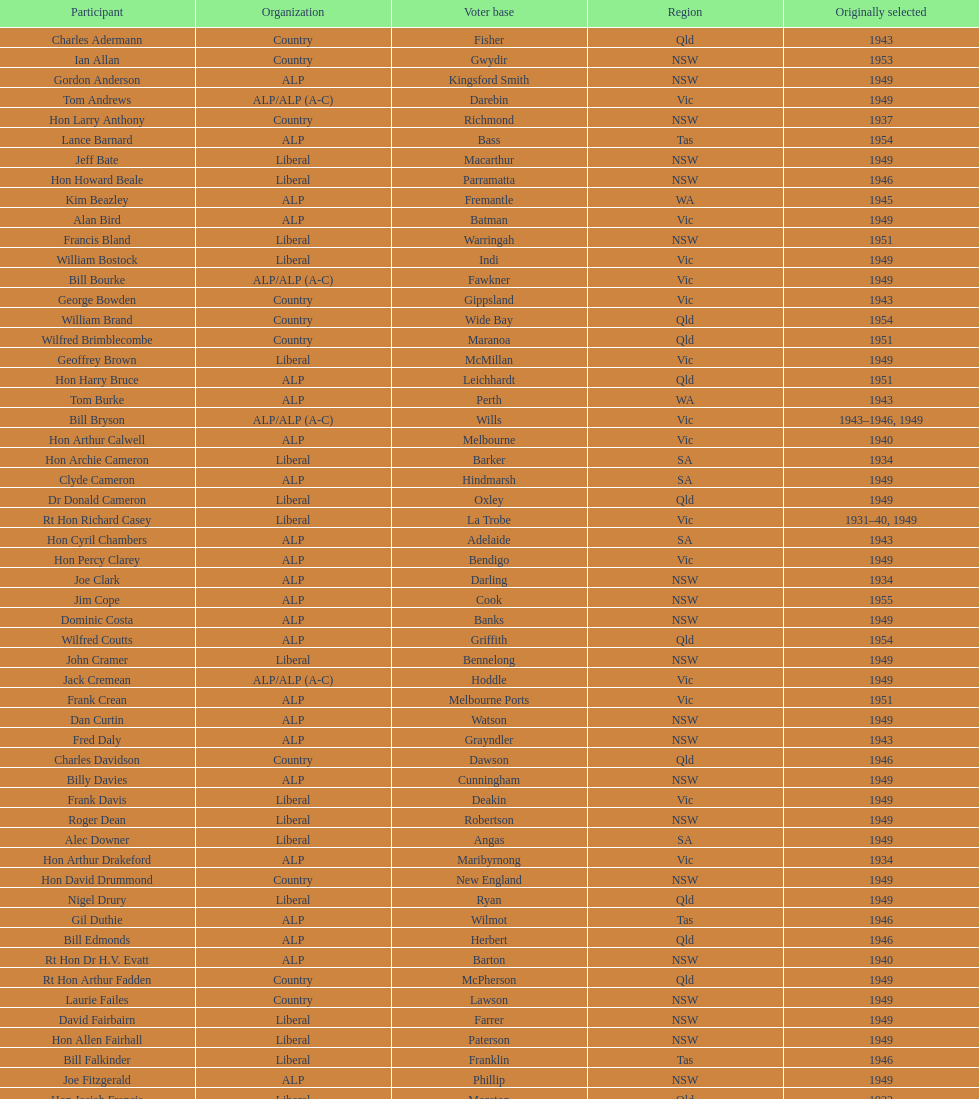Help me parse the entirety of this table. {'header': ['Participant', 'Organization', 'Voter base', 'Region', 'Originally selected'], 'rows': [['Charles Adermann', 'Country', 'Fisher', 'Qld', '1943'], ['Ian Allan', 'Country', 'Gwydir', 'NSW', '1953'], ['Gordon Anderson', 'ALP', 'Kingsford Smith', 'NSW', '1949'], ['Tom Andrews', 'ALP/ALP (A-C)', 'Darebin', 'Vic', '1949'], ['Hon Larry Anthony', 'Country', 'Richmond', 'NSW', '1937'], ['Lance Barnard', 'ALP', 'Bass', 'Tas', '1954'], ['Jeff Bate', 'Liberal', 'Macarthur', 'NSW', '1949'], ['Hon Howard Beale', 'Liberal', 'Parramatta', 'NSW', '1946'], ['Kim Beazley', 'ALP', 'Fremantle', 'WA', '1945'], ['Alan Bird', 'ALP', 'Batman', 'Vic', '1949'], ['Francis Bland', 'Liberal', 'Warringah', 'NSW', '1951'], ['William Bostock', 'Liberal', 'Indi', 'Vic', '1949'], ['Bill Bourke', 'ALP/ALP (A-C)', 'Fawkner', 'Vic', '1949'], ['George Bowden', 'Country', 'Gippsland', 'Vic', '1943'], ['William Brand', 'Country', 'Wide Bay', 'Qld', '1954'], ['Wilfred Brimblecombe', 'Country', 'Maranoa', 'Qld', '1951'], ['Geoffrey Brown', 'Liberal', 'McMillan', 'Vic', '1949'], ['Hon Harry Bruce', 'ALP', 'Leichhardt', 'Qld', '1951'], ['Tom Burke', 'ALP', 'Perth', 'WA', '1943'], ['Bill Bryson', 'ALP/ALP (A-C)', 'Wills', 'Vic', '1943–1946, 1949'], ['Hon Arthur Calwell', 'ALP', 'Melbourne', 'Vic', '1940'], ['Hon Archie Cameron', 'Liberal', 'Barker', 'SA', '1934'], ['Clyde Cameron', 'ALP', 'Hindmarsh', 'SA', '1949'], ['Dr Donald Cameron', 'Liberal', 'Oxley', 'Qld', '1949'], ['Rt Hon Richard Casey', 'Liberal', 'La Trobe', 'Vic', '1931–40, 1949'], ['Hon Cyril Chambers', 'ALP', 'Adelaide', 'SA', '1943'], ['Hon Percy Clarey', 'ALP', 'Bendigo', 'Vic', '1949'], ['Joe Clark', 'ALP', 'Darling', 'NSW', '1934'], ['Jim Cope', 'ALP', 'Cook', 'NSW', '1955'], ['Dominic Costa', 'ALP', 'Banks', 'NSW', '1949'], ['Wilfred Coutts', 'ALP', 'Griffith', 'Qld', '1954'], ['John Cramer', 'Liberal', 'Bennelong', 'NSW', '1949'], ['Jack Cremean', 'ALP/ALP (A-C)', 'Hoddle', 'Vic', '1949'], ['Frank Crean', 'ALP', 'Melbourne Ports', 'Vic', '1951'], ['Dan Curtin', 'ALP', 'Watson', 'NSW', '1949'], ['Fred Daly', 'ALP', 'Grayndler', 'NSW', '1943'], ['Charles Davidson', 'Country', 'Dawson', 'Qld', '1946'], ['Billy Davies', 'ALP', 'Cunningham', 'NSW', '1949'], ['Frank Davis', 'Liberal', 'Deakin', 'Vic', '1949'], ['Roger Dean', 'Liberal', 'Robertson', 'NSW', '1949'], ['Alec Downer', 'Liberal', 'Angas', 'SA', '1949'], ['Hon Arthur Drakeford', 'ALP', 'Maribyrnong', 'Vic', '1934'], ['Hon David Drummond', 'Country', 'New England', 'NSW', '1949'], ['Nigel Drury', 'Liberal', 'Ryan', 'Qld', '1949'], ['Gil Duthie', 'ALP', 'Wilmot', 'Tas', '1946'], ['Bill Edmonds', 'ALP', 'Herbert', 'Qld', '1946'], ['Rt Hon Dr H.V. Evatt', 'ALP', 'Barton', 'NSW', '1940'], ['Rt Hon Arthur Fadden', 'Country', 'McPherson', 'Qld', '1949'], ['Laurie Failes', 'Country', 'Lawson', 'NSW', '1949'], ['David Fairbairn', 'Liberal', 'Farrer', 'NSW', '1949'], ['Hon Allen Fairhall', 'Liberal', 'Paterson', 'NSW', '1949'], ['Bill Falkinder', 'Liberal', 'Franklin', 'Tas', '1946'], ['Joe Fitzgerald', 'ALP', 'Phillip', 'NSW', '1949'], ['Hon Josiah Francis', 'Liberal', 'Moreton', 'Qld', '1922'], ['Allan Fraser', 'ALP', 'Eden-Monaro', 'NSW', '1943'], ['Jim Fraser', 'ALP', 'Australian Capital Territory', 'ACT', '1951'], ['Gordon Freeth', 'Liberal', 'Forrest', 'WA', '1949'], ['Arthur Fuller', 'Country', 'Hume', 'NSW', '1943–49, 1951'], ['Pat Galvin', 'ALP', 'Kingston', 'SA', '1951'], ['Arthur Greenup', 'ALP', 'Dalley', 'NSW', '1953'], ['Charles Griffiths', 'ALP', 'Shortland', 'NSW', '1949'], ['Jo Gullett', 'Liberal', 'Henty', 'Vic', '1946'], ['Len Hamilton', 'Country', 'Canning', 'WA', '1946'], ['Rt Hon Eric Harrison', 'Liberal', 'Wentworth', 'NSW', '1931'], ['Jim Harrison', 'ALP', 'Blaxland', 'NSW', '1949'], ['Hon Paul Hasluck', 'Liberal', 'Curtin', 'WA', '1949'], ['Hon William Haworth', 'Liberal', 'Isaacs', 'Vic', '1949'], ['Leslie Haylen', 'ALP', 'Parkes', 'NSW', '1943'], ['Rt Hon Harold Holt', 'Liberal', 'Higgins', 'Vic', '1935'], ['John Howse', 'Liberal', 'Calare', 'NSW', '1946'], ['Alan Hulme', 'Liberal', 'Petrie', 'Qld', '1949'], ['William Jack', 'Liberal', 'North Sydney', 'NSW', '1949'], ['Rowley James', 'ALP', 'Hunter', 'NSW', '1928'], ['Hon Herbert Johnson', 'ALP', 'Kalgoorlie', 'WA', '1940'], ['Bob Joshua', 'ALP/ALP (A-C)', 'Ballaarat', 'ALP', '1951'], ['Percy Joske', 'Liberal', 'Balaclava', 'Vic', '1951'], ['Hon Wilfrid Kent Hughes', 'Liberal', 'Chisholm', 'Vic', '1949'], ['Stan Keon', 'ALP/ALP (A-C)', 'Yarra', 'Vic', '1949'], ['William Lawrence', 'Liberal', 'Wimmera', 'Vic', '1949'], ['Hon George Lawson', 'ALP', 'Brisbane', 'Qld', '1931'], ['Nelson Lemmon', 'ALP', 'St George', 'NSW', '1943–49, 1954'], ['Hugh Leslie', 'Liberal', 'Moore', 'Country', '1949'], ['Robert Lindsay', 'Liberal', 'Flinders', 'Vic', '1954'], ['Tony Luchetti', 'ALP', 'Macquarie', 'NSW', '1951'], ['Aubrey Luck', 'Liberal', 'Darwin', 'Tas', '1951'], ['Philip Lucock', 'Country', 'Lyne', 'NSW', '1953'], ['Dan Mackinnon', 'Liberal', 'Corangamite', 'Vic', '1949–51, 1953'], ['Hon Norman Makin', 'ALP', 'Sturt', 'SA', '1919–46, 1954'], ['Hon Philip McBride', 'Liberal', 'Wakefield', 'SA', '1931–37, 1937–43 (S), 1946'], ['Malcolm McColm', 'Liberal', 'Bowman', 'Qld', '1949'], ['Rt Hon John McEwen', 'Country', 'Murray', 'Vic', '1934'], ['John McLeay', 'Liberal', 'Boothby', 'SA', '1949'], ['Don McLeod', 'Liberal', 'Wannon', 'ALP', '1940–49, 1951'], ['Hon William McMahon', 'Liberal', 'Lowe', 'NSW', '1949'], ['Rt Hon Robert Menzies', 'Liberal', 'Kooyong', 'Vic', '1934'], ['Dan Minogue', 'ALP', 'West Sydney', 'NSW', '1949'], ['Charles Morgan', 'ALP', 'Reid', 'NSW', '1940–46, 1949'], ['Jack Mullens', 'ALP/ALP (A-C)', 'Gellibrand', 'Vic', '1949'], ['Jock Nelson', 'ALP', 'Northern Territory', 'NT', '1949'], ["William O'Connor", 'ALP', 'Martin', 'NSW', '1946'], ['Hubert Opperman', 'Liberal', 'Corio', 'Vic', '1949'], ['Hon Frederick Osborne', 'Liberal', 'Evans', 'NSW', '1949'], ['Rt Hon Sir Earle Page', 'Country', 'Cowper', 'NSW', '1919'], ['Henry Pearce', 'Liberal', 'Capricornia', 'Qld', '1949'], ['Ted Peters', 'ALP', 'Burke', 'Vic', '1949'], ['Hon Reg Pollard', 'ALP', 'Lalor', 'Vic', '1937'], ['Hon Bill Riordan', 'ALP', 'Kennedy', 'Qld', '1936'], ['Hugh Roberton', 'Country', 'Riverina', 'NSW', '1949'], ['Edgar Russell', 'ALP', 'Grey', 'SA', '1943'], ['Tom Sheehan', 'ALP', 'Cook', 'NSW', '1937'], ['Frank Stewart', 'ALP', 'Lang', 'NSW', '1953'], ['Reginald Swartz', 'Liberal', 'Darling Downs', 'Qld', '1949'], ['Albert Thompson', 'ALP', 'Port Adelaide', 'SA', '1946'], ['Frank Timson', 'Liberal', 'Higinbotham', 'Vic', '1949'], ['Hon Athol Townley', 'Liberal', 'Denison', 'Tas', '1949'], ['Winton Turnbull', 'Country', 'Mallee', 'Vic', '1946'], ['Harry Turner', 'Liberal', 'Bradfield', 'NSW', '1952'], ['Hon Eddie Ward', 'ALP', 'East Sydney', 'NSW', '1931, 1932'], ['David Oliver Watkins', 'ALP', 'Newcastle', 'NSW', '1935'], ['Harry Webb', 'ALP', 'Swan', 'WA', '1954'], ['William Wentworth', 'Liberal', 'Mackellar', 'NSW', '1949'], ['Roy Wheeler', 'Liberal', 'Mitchell', 'NSW', '1949'], ['Gough Whitlam', 'ALP', 'Werriwa', 'NSW', '1952'], ['Bruce Wight', 'Liberal', 'Lilley', 'Qld', '1949']]} Who was the first member to be elected? Charles Adermann. 